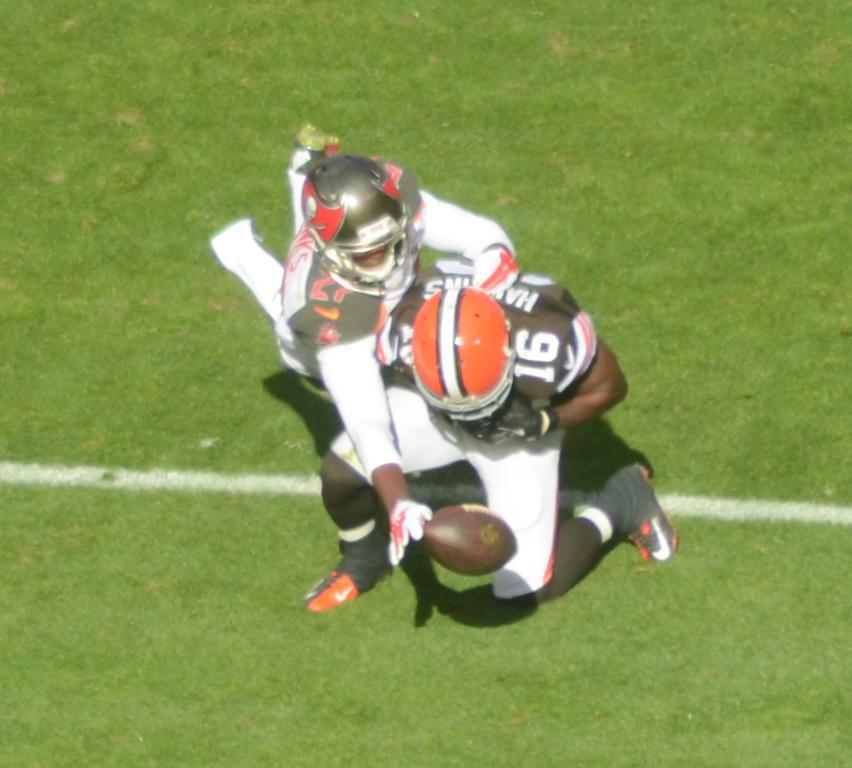Could you give a brief overview of what you see in this image? In the image we can see there are two people standing on the ground and there is a rugby ball in the air. The people are wearing helmets and the ground is covered with grass. 